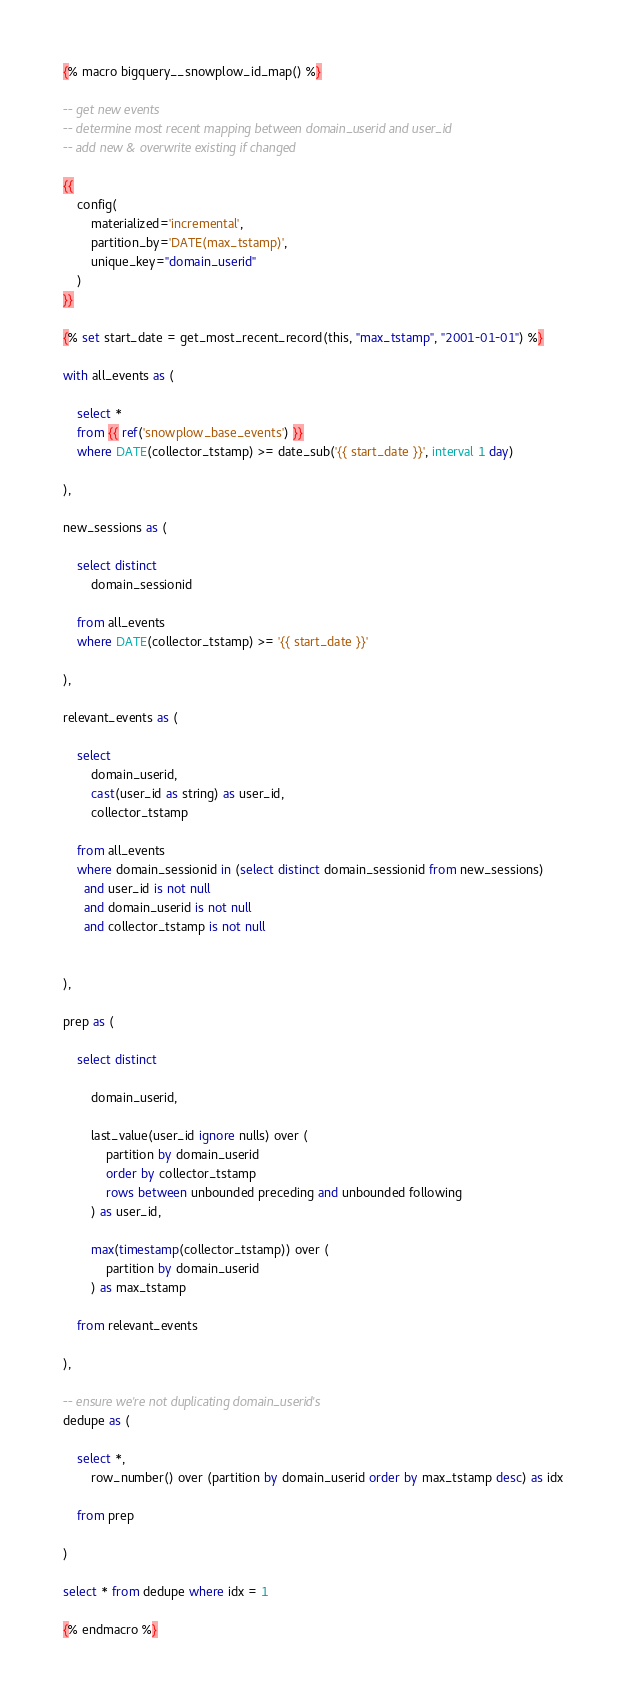Convert code to text. <code><loc_0><loc_0><loc_500><loc_500><_SQL_>
{% macro bigquery__snowplow_id_map() %}

-- get new events
-- determine most recent mapping between domain_userid and user_id
-- add new & overwrite existing if changed

{{
    config(
        materialized='incremental',
        partition_by='DATE(max_tstamp)',
        unique_key="domain_userid"
    )
}}

{% set start_date = get_most_recent_record(this, "max_tstamp", "2001-01-01") %}

with all_events as (

    select *
    from {{ ref('snowplow_base_events') }}
    where DATE(collector_tstamp) >= date_sub('{{ start_date }}', interval 1 day)

),

new_sessions as (

    select distinct
        domain_sessionid

    from all_events
    where DATE(collector_tstamp) >= '{{ start_date }}'

),

relevant_events as (

    select
        domain_userid,
        cast(user_id as string) as user_id,
        collector_tstamp

    from all_events
    where domain_sessionid in (select distinct domain_sessionid from new_sessions)
      and user_id is not null
      and domain_userid is not null
      and collector_tstamp is not null


),

prep as (

    select distinct

        domain_userid,

        last_value(user_id ignore nulls) over (
            partition by domain_userid
            order by collector_tstamp
            rows between unbounded preceding and unbounded following
        ) as user_id,

        max(timestamp(collector_tstamp)) over (
            partition by domain_userid
        ) as max_tstamp

    from relevant_events

),

-- ensure we're not duplicating domain_userid's
dedupe as (

    select *,
        row_number() over (partition by domain_userid order by max_tstamp desc) as idx

    from prep

)

select * from dedupe where idx = 1

{% endmacro %}
</code> 